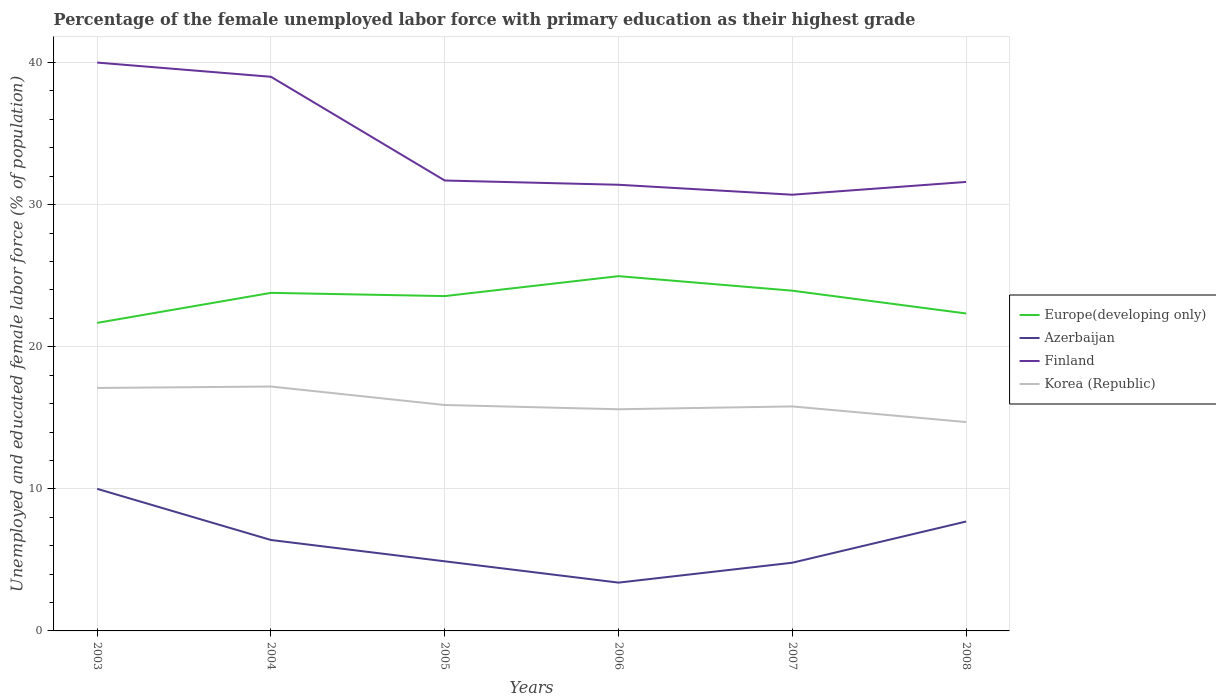How many different coloured lines are there?
Your answer should be compact. 4. Does the line corresponding to Azerbaijan intersect with the line corresponding to Finland?
Your response must be concise. No. Is the number of lines equal to the number of legend labels?
Offer a terse response. Yes. Across all years, what is the maximum percentage of the unemployed female labor force with primary education in Europe(developing only)?
Your answer should be compact. 21.68. In which year was the percentage of the unemployed female labor force with primary education in Finland maximum?
Provide a succinct answer. 2007. What is the total percentage of the unemployed female labor force with primary education in Europe(developing only) in the graph?
Your answer should be compact. -0.38. What is the difference between the highest and the second highest percentage of the unemployed female labor force with primary education in Azerbaijan?
Make the answer very short. 6.6. What is the difference between the highest and the lowest percentage of the unemployed female labor force with primary education in Korea (Republic)?
Your answer should be compact. 2. What is the difference between two consecutive major ticks on the Y-axis?
Provide a succinct answer. 10. Does the graph contain any zero values?
Ensure brevity in your answer.  No. What is the title of the graph?
Provide a succinct answer. Percentage of the female unemployed labor force with primary education as their highest grade. Does "Liberia" appear as one of the legend labels in the graph?
Keep it short and to the point. No. What is the label or title of the X-axis?
Offer a very short reply. Years. What is the label or title of the Y-axis?
Keep it short and to the point. Unemployed and educated female labor force (% of population). What is the Unemployed and educated female labor force (% of population) of Europe(developing only) in 2003?
Offer a very short reply. 21.68. What is the Unemployed and educated female labor force (% of population) of Finland in 2003?
Provide a short and direct response. 40. What is the Unemployed and educated female labor force (% of population) of Korea (Republic) in 2003?
Make the answer very short. 17.1. What is the Unemployed and educated female labor force (% of population) in Europe(developing only) in 2004?
Your answer should be very brief. 23.79. What is the Unemployed and educated female labor force (% of population) of Azerbaijan in 2004?
Give a very brief answer. 6.4. What is the Unemployed and educated female labor force (% of population) of Finland in 2004?
Provide a short and direct response. 39. What is the Unemployed and educated female labor force (% of population) of Korea (Republic) in 2004?
Keep it short and to the point. 17.2. What is the Unemployed and educated female labor force (% of population) of Europe(developing only) in 2005?
Offer a terse response. 23.57. What is the Unemployed and educated female labor force (% of population) of Azerbaijan in 2005?
Provide a short and direct response. 4.9. What is the Unemployed and educated female labor force (% of population) in Finland in 2005?
Provide a short and direct response. 31.7. What is the Unemployed and educated female labor force (% of population) of Korea (Republic) in 2005?
Provide a short and direct response. 15.9. What is the Unemployed and educated female labor force (% of population) in Europe(developing only) in 2006?
Offer a terse response. 24.97. What is the Unemployed and educated female labor force (% of population) of Azerbaijan in 2006?
Give a very brief answer. 3.4. What is the Unemployed and educated female labor force (% of population) in Finland in 2006?
Keep it short and to the point. 31.4. What is the Unemployed and educated female labor force (% of population) in Korea (Republic) in 2006?
Make the answer very short. 15.6. What is the Unemployed and educated female labor force (% of population) of Europe(developing only) in 2007?
Your answer should be very brief. 23.95. What is the Unemployed and educated female labor force (% of population) of Azerbaijan in 2007?
Your response must be concise. 4.8. What is the Unemployed and educated female labor force (% of population) in Finland in 2007?
Your answer should be very brief. 30.7. What is the Unemployed and educated female labor force (% of population) in Korea (Republic) in 2007?
Your response must be concise. 15.8. What is the Unemployed and educated female labor force (% of population) of Europe(developing only) in 2008?
Provide a short and direct response. 22.34. What is the Unemployed and educated female labor force (% of population) of Azerbaijan in 2008?
Offer a terse response. 7.7. What is the Unemployed and educated female labor force (% of population) in Finland in 2008?
Ensure brevity in your answer.  31.6. What is the Unemployed and educated female labor force (% of population) of Korea (Republic) in 2008?
Your answer should be compact. 14.7. Across all years, what is the maximum Unemployed and educated female labor force (% of population) in Europe(developing only)?
Provide a short and direct response. 24.97. Across all years, what is the maximum Unemployed and educated female labor force (% of population) of Finland?
Ensure brevity in your answer.  40. Across all years, what is the maximum Unemployed and educated female labor force (% of population) of Korea (Republic)?
Provide a succinct answer. 17.2. Across all years, what is the minimum Unemployed and educated female labor force (% of population) of Europe(developing only)?
Provide a short and direct response. 21.68. Across all years, what is the minimum Unemployed and educated female labor force (% of population) in Azerbaijan?
Your response must be concise. 3.4. Across all years, what is the minimum Unemployed and educated female labor force (% of population) in Finland?
Offer a terse response. 30.7. Across all years, what is the minimum Unemployed and educated female labor force (% of population) of Korea (Republic)?
Offer a terse response. 14.7. What is the total Unemployed and educated female labor force (% of population) in Europe(developing only) in the graph?
Your answer should be compact. 140.29. What is the total Unemployed and educated female labor force (% of population) of Azerbaijan in the graph?
Offer a very short reply. 37.2. What is the total Unemployed and educated female labor force (% of population) in Finland in the graph?
Provide a short and direct response. 204.4. What is the total Unemployed and educated female labor force (% of population) of Korea (Republic) in the graph?
Provide a succinct answer. 96.3. What is the difference between the Unemployed and educated female labor force (% of population) of Europe(developing only) in 2003 and that in 2004?
Offer a terse response. -2.11. What is the difference between the Unemployed and educated female labor force (% of population) in Finland in 2003 and that in 2004?
Your response must be concise. 1. What is the difference between the Unemployed and educated female labor force (% of population) in Korea (Republic) in 2003 and that in 2004?
Your answer should be compact. -0.1. What is the difference between the Unemployed and educated female labor force (% of population) of Europe(developing only) in 2003 and that in 2005?
Provide a short and direct response. -1.89. What is the difference between the Unemployed and educated female labor force (% of population) of Azerbaijan in 2003 and that in 2005?
Your answer should be compact. 5.1. What is the difference between the Unemployed and educated female labor force (% of population) of Europe(developing only) in 2003 and that in 2006?
Give a very brief answer. -3.29. What is the difference between the Unemployed and educated female labor force (% of population) in Azerbaijan in 2003 and that in 2006?
Your response must be concise. 6.6. What is the difference between the Unemployed and educated female labor force (% of population) in Korea (Republic) in 2003 and that in 2006?
Your response must be concise. 1.5. What is the difference between the Unemployed and educated female labor force (% of population) of Europe(developing only) in 2003 and that in 2007?
Make the answer very short. -2.27. What is the difference between the Unemployed and educated female labor force (% of population) in Finland in 2003 and that in 2007?
Provide a short and direct response. 9.3. What is the difference between the Unemployed and educated female labor force (% of population) of Europe(developing only) in 2003 and that in 2008?
Provide a succinct answer. -0.66. What is the difference between the Unemployed and educated female labor force (% of population) of Europe(developing only) in 2004 and that in 2005?
Offer a terse response. 0.23. What is the difference between the Unemployed and educated female labor force (% of population) in Azerbaijan in 2004 and that in 2005?
Keep it short and to the point. 1.5. What is the difference between the Unemployed and educated female labor force (% of population) in Finland in 2004 and that in 2005?
Your answer should be very brief. 7.3. What is the difference between the Unemployed and educated female labor force (% of population) of Korea (Republic) in 2004 and that in 2005?
Your answer should be compact. 1.3. What is the difference between the Unemployed and educated female labor force (% of population) of Europe(developing only) in 2004 and that in 2006?
Offer a terse response. -1.18. What is the difference between the Unemployed and educated female labor force (% of population) in Korea (Republic) in 2004 and that in 2006?
Offer a very short reply. 1.6. What is the difference between the Unemployed and educated female labor force (% of population) of Europe(developing only) in 2004 and that in 2007?
Make the answer very short. -0.15. What is the difference between the Unemployed and educated female labor force (% of population) of Azerbaijan in 2004 and that in 2007?
Your answer should be very brief. 1.6. What is the difference between the Unemployed and educated female labor force (% of population) of Korea (Republic) in 2004 and that in 2007?
Make the answer very short. 1.4. What is the difference between the Unemployed and educated female labor force (% of population) of Europe(developing only) in 2004 and that in 2008?
Ensure brevity in your answer.  1.45. What is the difference between the Unemployed and educated female labor force (% of population) of Azerbaijan in 2004 and that in 2008?
Keep it short and to the point. -1.3. What is the difference between the Unemployed and educated female labor force (% of population) of Europe(developing only) in 2005 and that in 2006?
Your answer should be compact. -1.4. What is the difference between the Unemployed and educated female labor force (% of population) of Azerbaijan in 2005 and that in 2006?
Keep it short and to the point. 1.5. What is the difference between the Unemployed and educated female labor force (% of population) of Finland in 2005 and that in 2006?
Your answer should be compact. 0.3. What is the difference between the Unemployed and educated female labor force (% of population) of Europe(developing only) in 2005 and that in 2007?
Make the answer very short. -0.38. What is the difference between the Unemployed and educated female labor force (% of population) in Europe(developing only) in 2005 and that in 2008?
Offer a terse response. 1.23. What is the difference between the Unemployed and educated female labor force (% of population) of Azerbaijan in 2005 and that in 2008?
Provide a succinct answer. -2.8. What is the difference between the Unemployed and educated female labor force (% of population) in Korea (Republic) in 2005 and that in 2008?
Your answer should be compact. 1.2. What is the difference between the Unemployed and educated female labor force (% of population) in Europe(developing only) in 2006 and that in 2007?
Your answer should be very brief. 1.02. What is the difference between the Unemployed and educated female labor force (% of population) of Azerbaijan in 2006 and that in 2007?
Make the answer very short. -1.4. What is the difference between the Unemployed and educated female labor force (% of population) of Finland in 2006 and that in 2007?
Ensure brevity in your answer.  0.7. What is the difference between the Unemployed and educated female labor force (% of population) in Korea (Republic) in 2006 and that in 2007?
Your answer should be very brief. -0.2. What is the difference between the Unemployed and educated female labor force (% of population) of Europe(developing only) in 2006 and that in 2008?
Provide a short and direct response. 2.63. What is the difference between the Unemployed and educated female labor force (% of population) of Azerbaijan in 2006 and that in 2008?
Offer a terse response. -4.3. What is the difference between the Unemployed and educated female labor force (% of population) in Europe(developing only) in 2007 and that in 2008?
Your answer should be very brief. 1.6. What is the difference between the Unemployed and educated female labor force (% of population) in Finland in 2007 and that in 2008?
Make the answer very short. -0.9. What is the difference between the Unemployed and educated female labor force (% of population) of Europe(developing only) in 2003 and the Unemployed and educated female labor force (% of population) of Azerbaijan in 2004?
Your response must be concise. 15.28. What is the difference between the Unemployed and educated female labor force (% of population) in Europe(developing only) in 2003 and the Unemployed and educated female labor force (% of population) in Finland in 2004?
Your response must be concise. -17.32. What is the difference between the Unemployed and educated female labor force (% of population) in Europe(developing only) in 2003 and the Unemployed and educated female labor force (% of population) in Korea (Republic) in 2004?
Provide a succinct answer. 4.48. What is the difference between the Unemployed and educated female labor force (% of population) of Azerbaijan in 2003 and the Unemployed and educated female labor force (% of population) of Korea (Republic) in 2004?
Provide a succinct answer. -7.2. What is the difference between the Unemployed and educated female labor force (% of population) in Finland in 2003 and the Unemployed and educated female labor force (% of population) in Korea (Republic) in 2004?
Your response must be concise. 22.8. What is the difference between the Unemployed and educated female labor force (% of population) in Europe(developing only) in 2003 and the Unemployed and educated female labor force (% of population) in Azerbaijan in 2005?
Ensure brevity in your answer.  16.78. What is the difference between the Unemployed and educated female labor force (% of population) of Europe(developing only) in 2003 and the Unemployed and educated female labor force (% of population) of Finland in 2005?
Your answer should be very brief. -10.02. What is the difference between the Unemployed and educated female labor force (% of population) in Europe(developing only) in 2003 and the Unemployed and educated female labor force (% of population) in Korea (Republic) in 2005?
Ensure brevity in your answer.  5.78. What is the difference between the Unemployed and educated female labor force (% of population) in Azerbaijan in 2003 and the Unemployed and educated female labor force (% of population) in Finland in 2005?
Your response must be concise. -21.7. What is the difference between the Unemployed and educated female labor force (% of population) of Azerbaijan in 2003 and the Unemployed and educated female labor force (% of population) of Korea (Republic) in 2005?
Your answer should be compact. -5.9. What is the difference between the Unemployed and educated female labor force (% of population) in Finland in 2003 and the Unemployed and educated female labor force (% of population) in Korea (Republic) in 2005?
Offer a very short reply. 24.1. What is the difference between the Unemployed and educated female labor force (% of population) of Europe(developing only) in 2003 and the Unemployed and educated female labor force (% of population) of Azerbaijan in 2006?
Offer a very short reply. 18.28. What is the difference between the Unemployed and educated female labor force (% of population) of Europe(developing only) in 2003 and the Unemployed and educated female labor force (% of population) of Finland in 2006?
Provide a succinct answer. -9.72. What is the difference between the Unemployed and educated female labor force (% of population) in Europe(developing only) in 2003 and the Unemployed and educated female labor force (% of population) in Korea (Republic) in 2006?
Give a very brief answer. 6.08. What is the difference between the Unemployed and educated female labor force (% of population) of Azerbaijan in 2003 and the Unemployed and educated female labor force (% of population) of Finland in 2006?
Offer a terse response. -21.4. What is the difference between the Unemployed and educated female labor force (% of population) in Azerbaijan in 2003 and the Unemployed and educated female labor force (% of population) in Korea (Republic) in 2006?
Provide a succinct answer. -5.6. What is the difference between the Unemployed and educated female labor force (% of population) of Finland in 2003 and the Unemployed and educated female labor force (% of population) of Korea (Republic) in 2006?
Make the answer very short. 24.4. What is the difference between the Unemployed and educated female labor force (% of population) of Europe(developing only) in 2003 and the Unemployed and educated female labor force (% of population) of Azerbaijan in 2007?
Ensure brevity in your answer.  16.88. What is the difference between the Unemployed and educated female labor force (% of population) in Europe(developing only) in 2003 and the Unemployed and educated female labor force (% of population) in Finland in 2007?
Ensure brevity in your answer.  -9.02. What is the difference between the Unemployed and educated female labor force (% of population) of Europe(developing only) in 2003 and the Unemployed and educated female labor force (% of population) of Korea (Republic) in 2007?
Ensure brevity in your answer.  5.88. What is the difference between the Unemployed and educated female labor force (% of population) of Azerbaijan in 2003 and the Unemployed and educated female labor force (% of population) of Finland in 2007?
Offer a very short reply. -20.7. What is the difference between the Unemployed and educated female labor force (% of population) of Azerbaijan in 2003 and the Unemployed and educated female labor force (% of population) of Korea (Republic) in 2007?
Provide a short and direct response. -5.8. What is the difference between the Unemployed and educated female labor force (% of population) in Finland in 2003 and the Unemployed and educated female labor force (% of population) in Korea (Republic) in 2007?
Provide a succinct answer. 24.2. What is the difference between the Unemployed and educated female labor force (% of population) of Europe(developing only) in 2003 and the Unemployed and educated female labor force (% of population) of Azerbaijan in 2008?
Offer a terse response. 13.98. What is the difference between the Unemployed and educated female labor force (% of population) of Europe(developing only) in 2003 and the Unemployed and educated female labor force (% of population) of Finland in 2008?
Provide a succinct answer. -9.92. What is the difference between the Unemployed and educated female labor force (% of population) in Europe(developing only) in 2003 and the Unemployed and educated female labor force (% of population) in Korea (Republic) in 2008?
Provide a succinct answer. 6.98. What is the difference between the Unemployed and educated female labor force (% of population) in Azerbaijan in 2003 and the Unemployed and educated female labor force (% of population) in Finland in 2008?
Offer a terse response. -21.6. What is the difference between the Unemployed and educated female labor force (% of population) of Azerbaijan in 2003 and the Unemployed and educated female labor force (% of population) of Korea (Republic) in 2008?
Your answer should be compact. -4.7. What is the difference between the Unemployed and educated female labor force (% of population) of Finland in 2003 and the Unemployed and educated female labor force (% of population) of Korea (Republic) in 2008?
Offer a very short reply. 25.3. What is the difference between the Unemployed and educated female labor force (% of population) in Europe(developing only) in 2004 and the Unemployed and educated female labor force (% of population) in Azerbaijan in 2005?
Your answer should be compact. 18.89. What is the difference between the Unemployed and educated female labor force (% of population) in Europe(developing only) in 2004 and the Unemployed and educated female labor force (% of population) in Finland in 2005?
Offer a very short reply. -7.91. What is the difference between the Unemployed and educated female labor force (% of population) of Europe(developing only) in 2004 and the Unemployed and educated female labor force (% of population) of Korea (Republic) in 2005?
Provide a succinct answer. 7.89. What is the difference between the Unemployed and educated female labor force (% of population) of Azerbaijan in 2004 and the Unemployed and educated female labor force (% of population) of Finland in 2005?
Your answer should be very brief. -25.3. What is the difference between the Unemployed and educated female labor force (% of population) of Azerbaijan in 2004 and the Unemployed and educated female labor force (% of population) of Korea (Republic) in 2005?
Your response must be concise. -9.5. What is the difference between the Unemployed and educated female labor force (% of population) of Finland in 2004 and the Unemployed and educated female labor force (% of population) of Korea (Republic) in 2005?
Offer a very short reply. 23.1. What is the difference between the Unemployed and educated female labor force (% of population) in Europe(developing only) in 2004 and the Unemployed and educated female labor force (% of population) in Azerbaijan in 2006?
Provide a short and direct response. 20.39. What is the difference between the Unemployed and educated female labor force (% of population) of Europe(developing only) in 2004 and the Unemployed and educated female labor force (% of population) of Finland in 2006?
Your answer should be very brief. -7.61. What is the difference between the Unemployed and educated female labor force (% of population) in Europe(developing only) in 2004 and the Unemployed and educated female labor force (% of population) in Korea (Republic) in 2006?
Make the answer very short. 8.19. What is the difference between the Unemployed and educated female labor force (% of population) of Azerbaijan in 2004 and the Unemployed and educated female labor force (% of population) of Korea (Republic) in 2006?
Ensure brevity in your answer.  -9.2. What is the difference between the Unemployed and educated female labor force (% of population) in Finland in 2004 and the Unemployed and educated female labor force (% of population) in Korea (Republic) in 2006?
Keep it short and to the point. 23.4. What is the difference between the Unemployed and educated female labor force (% of population) of Europe(developing only) in 2004 and the Unemployed and educated female labor force (% of population) of Azerbaijan in 2007?
Offer a very short reply. 18.99. What is the difference between the Unemployed and educated female labor force (% of population) in Europe(developing only) in 2004 and the Unemployed and educated female labor force (% of population) in Finland in 2007?
Keep it short and to the point. -6.91. What is the difference between the Unemployed and educated female labor force (% of population) of Europe(developing only) in 2004 and the Unemployed and educated female labor force (% of population) of Korea (Republic) in 2007?
Provide a short and direct response. 7.99. What is the difference between the Unemployed and educated female labor force (% of population) in Azerbaijan in 2004 and the Unemployed and educated female labor force (% of population) in Finland in 2007?
Offer a terse response. -24.3. What is the difference between the Unemployed and educated female labor force (% of population) of Finland in 2004 and the Unemployed and educated female labor force (% of population) of Korea (Republic) in 2007?
Offer a terse response. 23.2. What is the difference between the Unemployed and educated female labor force (% of population) in Europe(developing only) in 2004 and the Unemployed and educated female labor force (% of population) in Azerbaijan in 2008?
Offer a very short reply. 16.09. What is the difference between the Unemployed and educated female labor force (% of population) in Europe(developing only) in 2004 and the Unemployed and educated female labor force (% of population) in Finland in 2008?
Provide a succinct answer. -7.81. What is the difference between the Unemployed and educated female labor force (% of population) of Europe(developing only) in 2004 and the Unemployed and educated female labor force (% of population) of Korea (Republic) in 2008?
Make the answer very short. 9.09. What is the difference between the Unemployed and educated female labor force (% of population) of Azerbaijan in 2004 and the Unemployed and educated female labor force (% of population) of Finland in 2008?
Keep it short and to the point. -25.2. What is the difference between the Unemployed and educated female labor force (% of population) in Azerbaijan in 2004 and the Unemployed and educated female labor force (% of population) in Korea (Republic) in 2008?
Give a very brief answer. -8.3. What is the difference between the Unemployed and educated female labor force (% of population) of Finland in 2004 and the Unemployed and educated female labor force (% of population) of Korea (Republic) in 2008?
Your answer should be compact. 24.3. What is the difference between the Unemployed and educated female labor force (% of population) of Europe(developing only) in 2005 and the Unemployed and educated female labor force (% of population) of Azerbaijan in 2006?
Your answer should be compact. 20.17. What is the difference between the Unemployed and educated female labor force (% of population) in Europe(developing only) in 2005 and the Unemployed and educated female labor force (% of population) in Finland in 2006?
Your answer should be very brief. -7.83. What is the difference between the Unemployed and educated female labor force (% of population) in Europe(developing only) in 2005 and the Unemployed and educated female labor force (% of population) in Korea (Republic) in 2006?
Your answer should be compact. 7.97. What is the difference between the Unemployed and educated female labor force (% of population) in Azerbaijan in 2005 and the Unemployed and educated female labor force (% of population) in Finland in 2006?
Your answer should be very brief. -26.5. What is the difference between the Unemployed and educated female labor force (% of population) of Europe(developing only) in 2005 and the Unemployed and educated female labor force (% of population) of Azerbaijan in 2007?
Provide a succinct answer. 18.77. What is the difference between the Unemployed and educated female labor force (% of population) of Europe(developing only) in 2005 and the Unemployed and educated female labor force (% of population) of Finland in 2007?
Make the answer very short. -7.13. What is the difference between the Unemployed and educated female labor force (% of population) of Europe(developing only) in 2005 and the Unemployed and educated female labor force (% of population) of Korea (Republic) in 2007?
Your answer should be very brief. 7.77. What is the difference between the Unemployed and educated female labor force (% of population) in Azerbaijan in 2005 and the Unemployed and educated female labor force (% of population) in Finland in 2007?
Make the answer very short. -25.8. What is the difference between the Unemployed and educated female labor force (% of population) of Azerbaijan in 2005 and the Unemployed and educated female labor force (% of population) of Korea (Republic) in 2007?
Give a very brief answer. -10.9. What is the difference between the Unemployed and educated female labor force (% of population) in Europe(developing only) in 2005 and the Unemployed and educated female labor force (% of population) in Azerbaijan in 2008?
Your answer should be compact. 15.87. What is the difference between the Unemployed and educated female labor force (% of population) in Europe(developing only) in 2005 and the Unemployed and educated female labor force (% of population) in Finland in 2008?
Offer a terse response. -8.03. What is the difference between the Unemployed and educated female labor force (% of population) in Europe(developing only) in 2005 and the Unemployed and educated female labor force (% of population) in Korea (Republic) in 2008?
Your response must be concise. 8.87. What is the difference between the Unemployed and educated female labor force (% of population) in Azerbaijan in 2005 and the Unemployed and educated female labor force (% of population) in Finland in 2008?
Make the answer very short. -26.7. What is the difference between the Unemployed and educated female labor force (% of population) in Azerbaijan in 2005 and the Unemployed and educated female labor force (% of population) in Korea (Republic) in 2008?
Your response must be concise. -9.8. What is the difference between the Unemployed and educated female labor force (% of population) in Europe(developing only) in 2006 and the Unemployed and educated female labor force (% of population) in Azerbaijan in 2007?
Offer a very short reply. 20.17. What is the difference between the Unemployed and educated female labor force (% of population) of Europe(developing only) in 2006 and the Unemployed and educated female labor force (% of population) of Finland in 2007?
Your answer should be very brief. -5.73. What is the difference between the Unemployed and educated female labor force (% of population) of Europe(developing only) in 2006 and the Unemployed and educated female labor force (% of population) of Korea (Republic) in 2007?
Offer a very short reply. 9.17. What is the difference between the Unemployed and educated female labor force (% of population) in Azerbaijan in 2006 and the Unemployed and educated female labor force (% of population) in Finland in 2007?
Keep it short and to the point. -27.3. What is the difference between the Unemployed and educated female labor force (% of population) in Finland in 2006 and the Unemployed and educated female labor force (% of population) in Korea (Republic) in 2007?
Offer a very short reply. 15.6. What is the difference between the Unemployed and educated female labor force (% of population) of Europe(developing only) in 2006 and the Unemployed and educated female labor force (% of population) of Azerbaijan in 2008?
Offer a very short reply. 17.27. What is the difference between the Unemployed and educated female labor force (% of population) of Europe(developing only) in 2006 and the Unemployed and educated female labor force (% of population) of Finland in 2008?
Provide a short and direct response. -6.63. What is the difference between the Unemployed and educated female labor force (% of population) of Europe(developing only) in 2006 and the Unemployed and educated female labor force (% of population) of Korea (Republic) in 2008?
Ensure brevity in your answer.  10.27. What is the difference between the Unemployed and educated female labor force (% of population) of Azerbaijan in 2006 and the Unemployed and educated female labor force (% of population) of Finland in 2008?
Offer a terse response. -28.2. What is the difference between the Unemployed and educated female labor force (% of population) in Finland in 2006 and the Unemployed and educated female labor force (% of population) in Korea (Republic) in 2008?
Your answer should be compact. 16.7. What is the difference between the Unemployed and educated female labor force (% of population) of Europe(developing only) in 2007 and the Unemployed and educated female labor force (% of population) of Azerbaijan in 2008?
Provide a short and direct response. 16.25. What is the difference between the Unemployed and educated female labor force (% of population) in Europe(developing only) in 2007 and the Unemployed and educated female labor force (% of population) in Finland in 2008?
Offer a terse response. -7.65. What is the difference between the Unemployed and educated female labor force (% of population) of Europe(developing only) in 2007 and the Unemployed and educated female labor force (% of population) of Korea (Republic) in 2008?
Provide a succinct answer. 9.25. What is the difference between the Unemployed and educated female labor force (% of population) in Azerbaijan in 2007 and the Unemployed and educated female labor force (% of population) in Finland in 2008?
Your answer should be very brief. -26.8. What is the average Unemployed and educated female labor force (% of population) in Europe(developing only) per year?
Ensure brevity in your answer.  23.38. What is the average Unemployed and educated female labor force (% of population) of Finland per year?
Keep it short and to the point. 34.07. What is the average Unemployed and educated female labor force (% of population) in Korea (Republic) per year?
Make the answer very short. 16.05. In the year 2003, what is the difference between the Unemployed and educated female labor force (% of population) of Europe(developing only) and Unemployed and educated female labor force (% of population) of Azerbaijan?
Provide a succinct answer. 11.68. In the year 2003, what is the difference between the Unemployed and educated female labor force (% of population) of Europe(developing only) and Unemployed and educated female labor force (% of population) of Finland?
Offer a terse response. -18.32. In the year 2003, what is the difference between the Unemployed and educated female labor force (% of population) in Europe(developing only) and Unemployed and educated female labor force (% of population) in Korea (Republic)?
Give a very brief answer. 4.58. In the year 2003, what is the difference between the Unemployed and educated female labor force (% of population) of Azerbaijan and Unemployed and educated female labor force (% of population) of Finland?
Your answer should be very brief. -30. In the year 2003, what is the difference between the Unemployed and educated female labor force (% of population) in Azerbaijan and Unemployed and educated female labor force (% of population) in Korea (Republic)?
Make the answer very short. -7.1. In the year 2003, what is the difference between the Unemployed and educated female labor force (% of population) of Finland and Unemployed and educated female labor force (% of population) of Korea (Republic)?
Make the answer very short. 22.9. In the year 2004, what is the difference between the Unemployed and educated female labor force (% of population) in Europe(developing only) and Unemployed and educated female labor force (% of population) in Azerbaijan?
Offer a very short reply. 17.39. In the year 2004, what is the difference between the Unemployed and educated female labor force (% of population) in Europe(developing only) and Unemployed and educated female labor force (% of population) in Finland?
Provide a short and direct response. -15.21. In the year 2004, what is the difference between the Unemployed and educated female labor force (% of population) of Europe(developing only) and Unemployed and educated female labor force (% of population) of Korea (Republic)?
Offer a terse response. 6.59. In the year 2004, what is the difference between the Unemployed and educated female labor force (% of population) of Azerbaijan and Unemployed and educated female labor force (% of population) of Finland?
Provide a short and direct response. -32.6. In the year 2004, what is the difference between the Unemployed and educated female labor force (% of population) of Azerbaijan and Unemployed and educated female labor force (% of population) of Korea (Republic)?
Ensure brevity in your answer.  -10.8. In the year 2004, what is the difference between the Unemployed and educated female labor force (% of population) of Finland and Unemployed and educated female labor force (% of population) of Korea (Republic)?
Make the answer very short. 21.8. In the year 2005, what is the difference between the Unemployed and educated female labor force (% of population) of Europe(developing only) and Unemployed and educated female labor force (% of population) of Azerbaijan?
Your answer should be compact. 18.67. In the year 2005, what is the difference between the Unemployed and educated female labor force (% of population) of Europe(developing only) and Unemployed and educated female labor force (% of population) of Finland?
Your answer should be very brief. -8.13. In the year 2005, what is the difference between the Unemployed and educated female labor force (% of population) in Europe(developing only) and Unemployed and educated female labor force (% of population) in Korea (Republic)?
Your answer should be very brief. 7.67. In the year 2005, what is the difference between the Unemployed and educated female labor force (% of population) of Azerbaijan and Unemployed and educated female labor force (% of population) of Finland?
Provide a short and direct response. -26.8. In the year 2005, what is the difference between the Unemployed and educated female labor force (% of population) in Finland and Unemployed and educated female labor force (% of population) in Korea (Republic)?
Your answer should be compact. 15.8. In the year 2006, what is the difference between the Unemployed and educated female labor force (% of population) in Europe(developing only) and Unemployed and educated female labor force (% of population) in Azerbaijan?
Your response must be concise. 21.57. In the year 2006, what is the difference between the Unemployed and educated female labor force (% of population) in Europe(developing only) and Unemployed and educated female labor force (% of population) in Finland?
Offer a terse response. -6.43. In the year 2006, what is the difference between the Unemployed and educated female labor force (% of population) in Europe(developing only) and Unemployed and educated female labor force (% of population) in Korea (Republic)?
Offer a very short reply. 9.37. In the year 2006, what is the difference between the Unemployed and educated female labor force (% of population) of Azerbaijan and Unemployed and educated female labor force (% of population) of Finland?
Provide a succinct answer. -28. In the year 2006, what is the difference between the Unemployed and educated female labor force (% of population) in Azerbaijan and Unemployed and educated female labor force (% of population) in Korea (Republic)?
Offer a terse response. -12.2. In the year 2007, what is the difference between the Unemployed and educated female labor force (% of population) in Europe(developing only) and Unemployed and educated female labor force (% of population) in Azerbaijan?
Your answer should be compact. 19.15. In the year 2007, what is the difference between the Unemployed and educated female labor force (% of population) in Europe(developing only) and Unemployed and educated female labor force (% of population) in Finland?
Keep it short and to the point. -6.75. In the year 2007, what is the difference between the Unemployed and educated female labor force (% of population) of Europe(developing only) and Unemployed and educated female labor force (% of population) of Korea (Republic)?
Keep it short and to the point. 8.15. In the year 2007, what is the difference between the Unemployed and educated female labor force (% of population) in Azerbaijan and Unemployed and educated female labor force (% of population) in Finland?
Your response must be concise. -25.9. In the year 2007, what is the difference between the Unemployed and educated female labor force (% of population) of Finland and Unemployed and educated female labor force (% of population) of Korea (Republic)?
Your answer should be compact. 14.9. In the year 2008, what is the difference between the Unemployed and educated female labor force (% of population) in Europe(developing only) and Unemployed and educated female labor force (% of population) in Azerbaijan?
Offer a very short reply. 14.64. In the year 2008, what is the difference between the Unemployed and educated female labor force (% of population) of Europe(developing only) and Unemployed and educated female labor force (% of population) of Finland?
Provide a succinct answer. -9.26. In the year 2008, what is the difference between the Unemployed and educated female labor force (% of population) of Europe(developing only) and Unemployed and educated female labor force (% of population) of Korea (Republic)?
Offer a terse response. 7.64. In the year 2008, what is the difference between the Unemployed and educated female labor force (% of population) of Azerbaijan and Unemployed and educated female labor force (% of population) of Finland?
Provide a succinct answer. -23.9. What is the ratio of the Unemployed and educated female labor force (% of population) of Europe(developing only) in 2003 to that in 2004?
Make the answer very short. 0.91. What is the ratio of the Unemployed and educated female labor force (% of population) in Azerbaijan in 2003 to that in 2004?
Provide a succinct answer. 1.56. What is the ratio of the Unemployed and educated female labor force (% of population) in Finland in 2003 to that in 2004?
Make the answer very short. 1.03. What is the ratio of the Unemployed and educated female labor force (% of population) of Korea (Republic) in 2003 to that in 2004?
Your answer should be very brief. 0.99. What is the ratio of the Unemployed and educated female labor force (% of population) of Europe(developing only) in 2003 to that in 2005?
Your answer should be compact. 0.92. What is the ratio of the Unemployed and educated female labor force (% of population) in Azerbaijan in 2003 to that in 2005?
Offer a terse response. 2.04. What is the ratio of the Unemployed and educated female labor force (% of population) in Finland in 2003 to that in 2005?
Give a very brief answer. 1.26. What is the ratio of the Unemployed and educated female labor force (% of population) in Korea (Republic) in 2003 to that in 2005?
Provide a short and direct response. 1.08. What is the ratio of the Unemployed and educated female labor force (% of population) of Europe(developing only) in 2003 to that in 2006?
Offer a terse response. 0.87. What is the ratio of the Unemployed and educated female labor force (% of population) in Azerbaijan in 2003 to that in 2006?
Offer a terse response. 2.94. What is the ratio of the Unemployed and educated female labor force (% of population) in Finland in 2003 to that in 2006?
Your response must be concise. 1.27. What is the ratio of the Unemployed and educated female labor force (% of population) of Korea (Republic) in 2003 to that in 2006?
Make the answer very short. 1.1. What is the ratio of the Unemployed and educated female labor force (% of population) of Europe(developing only) in 2003 to that in 2007?
Keep it short and to the point. 0.91. What is the ratio of the Unemployed and educated female labor force (% of population) in Azerbaijan in 2003 to that in 2007?
Offer a very short reply. 2.08. What is the ratio of the Unemployed and educated female labor force (% of population) of Finland in 2003 to that in 2007?
Ensure brevity in your answer.  1.3. What is the ratio of the Unemployed and educated female labor force (% of population) of Korea (Republic) in 2003 to that in 2007?
Your response must be concise. 1.08. What is the ratio of the Unemployed and educated female labor force (% of population) of Europe(developing only) in 2003 to that in 2008?
Offer a very short reply. 0.97. What is the ratio of the Unemployed and educated female labor force (% of population) in Azerbaijan in 2003 to that in 2008?
Your answer should be very brief. 1.3. What is the ratio of the Unemployed and educated female labor force (% of population) of Finland in 2003 to that in 2008?
Provide a short and direct response. 1.27. What is the ratio of the Unemployed and educated female labor force (% of population) in Korea (Republic) in 2003 to that in 2008?
Your answer should be very brief. 1.16. What is the ratio of the Unemployed and educated female labor force (% of population) of Europe(developing only) in 2004 to that in 2005?
Provide a succinct answer. 1.01. What is the ratio of the Unemployed and educated female labor force (% of population) in Azerbaijan in 2004 to that in 2005?
Offer a terse response. 1.31. What is the ratio of the Unemployed and educated female labor force (% of population) in Finland in 2004 to that in 2005?
Offer a terse response. 1.23. What is the ratio of the Unemployed and educated female labor force (% of population) of Korea (Republic) in 2004 to that in 2005?
Your answer should be compact. 1.08. What is the ratio of the Unemployed and educated female labor force (% of population) of Europe(developing only) in 2004 to that in 2006?
Make the answer very short. 0.95. What is the ratio of the Unemployed and educated female labor force (% of population) in Azerbaijan in 2004 to that in 2006?
Ensure brevity in your answer.  1.88. What is the ratio of the Unemployed and educated female labor force (% of population) of Finland in 2004 to that in 2006?
Make the answer very short. 1.24. What is the ratio of the Unemployed and educated female labor force (% of population) of Korea (Republic) in 2004 to that in 2006?
Give a very brief answer. 1.1. What is the ratio of the Unemployed and educated female labor force (% of population) in Finland in 2004 to that in 2007?
Your response must be concise. 1.27. What is the ratio of the Unemployed and educated female labor force (% of population) of Korea (Republic) in 2004 to that in 2007?
Your answer should be very brief. 1.09. What is the ratio of the Unemployed and educated female labor force (% of population) of Europe(developing only) in 2004 to that in 2008?
Provide a succinct answer. 1.06. What is the ratio of the Unemployed and educated female labor force (% of population) of Azerbaijan in 2004 to that in 2008?
Provide a succinct answer. 0.83. What is the ratio of the Unemployed and educated female labor force (% of population) in Finland in 2004 to that in 2008?
Provide a short and direct response. 1.23. What is the ratio of the Unemployed and educated female labor force (% of population) of Korea (Republic) in 2004 to that in 2008?
Provide a succinct answer. 1.17. What is the ratio of the Unemployed and educated female labor force (% of population) in Europe(developing only) in 2005 to that in 2006?
Keep it short and to the point. 0.94. What is the ratio of the Unemployed and educated female labor force (% of population) in Azerbaijan in 2005 to that in 2006?
Provide a succinct answer. 1.44. What is the ratio of the Unemployed and educated female labor force (% of population) in Finland in 2005 to that in 2006?
Offer a very short reply. 1.01. What is the ratio of the Unemployed and educated female labor force (% of population) in Korea (Republic) in 2005 to that in 2006?
Keep it short and to the point. 1.02. What is the ratio of the Unemployed and educated female labor force (% of population) in Europe(developing only) in 2005 to that in 2007?
Your answer should be very brief. 0.98. What is the ratio of the Unemployed and educated female labor force (% of population) in Azerbaijan in 2005 to that in 2007?
Offer a terse response. 1.02. What is the ratio of the Unemployed and educated female labor force (% of population) in Finland in 2005 to that in 2007?
Offer a very short reply. 1.03. What is the ratio of the Unemployed and educated female labor force (% of population) of Europe(developing only) in 2005 to that in 2008?
Make the answer very short. 1.05. What is the ratio of the Unemployed and educated female labor force (% of population) of Azerbaijan in 2005 to that in 2008?
Your response must be concise. 0.64. What is the ratio of the Unemployed and educated female labor force (% of population) of Korea (Republic) in 2005 to that in 2008?
Keep it short and to the point. 1.08. What is the ratio of the Unemployed and educated female labor force (% of population) of Europe(developing only) in 2006 to that in 2007?
Your response must be concise. 1.04. What is the ratio of the Unemployed and educated female labor force (% of population) in Azerbaijan in 2006 to that in 2007?
Keep it short and to the point. 0.71. What is the ratio of the Unemployed and educated female labor force (% of population) in Finland in 2006 to that in 2007?
Give a very brief answer. 1.02. What is the ratio of the Unemployed and educated female labor force (% of population) of Korea (Republic) in 2006 to that in 2007?
Keep it short and to the point. 0.99. What is the ratio of the Unemployed and educated female labor force (% of population) in Europe(developing only) in 2006 to that in 2008?
Offer a very short reply. 1.12. What is the ratio of the Unemployed and educated female labor force (% of population) in Azerbaijan in 2006 to that in 2008?
Your response must be concise. 0.44. What is the ratio of the Unemployed and educated female labor force (% of population) of Korea (Republic) in 2006 to that in 2008?
Your response must be concise. 1.06. What is the ratio of the Unemployed and educated female labor force (% of population) of Europe(developing only) in 2007 to that in 2008?
Ensure brevity in your answer.  1.07. What is the ratio of the Unemployed and educated female labor force (% of population) of Azerbaijan in 2007 to that in 2008?
Offer a very short reply. 0.62. What is the ratio of the Unemployed and educated female labor force (% of population) in Finland in 2007 to that in 2008?
Your answer should be compact. 0.97. What is the ratio of the Unemployed and educated female labor force (% of population) in Korea (Republic) in 2007 to that in 2008?
Your answer should be compact. 1.07. What is the difference between the highest and the second highest Unemployed and educated female labor force (% of population) in Europe(developing only)?
Your response must be concise. 1.02. What is the difference between the highest and the second highest Unemployed and educated female labor force (% of population) of Azerbaijan?
Your response must be concise. 2.3. What is the difference between the highest and the lowest Unemployed and educated female labor force (% of population) in Europe(developing only)?
Keep it short and to the point. 3.29. What is the difference between the highest and the lowest Unemployed and educated female labor force (% of population) in Azerbaijan?
Your answer should be very brief. 6.6. What is the difference between the highest and the lowest Unemployed and educated female labor force (% of population) of Finland?
Offer a terse response. 9.3. What is the difference between the highest and the lowest Unemployed and educated female labor force (% of population) in Korea (Republic)?
Ensure brevity in your answer.  2.5. 